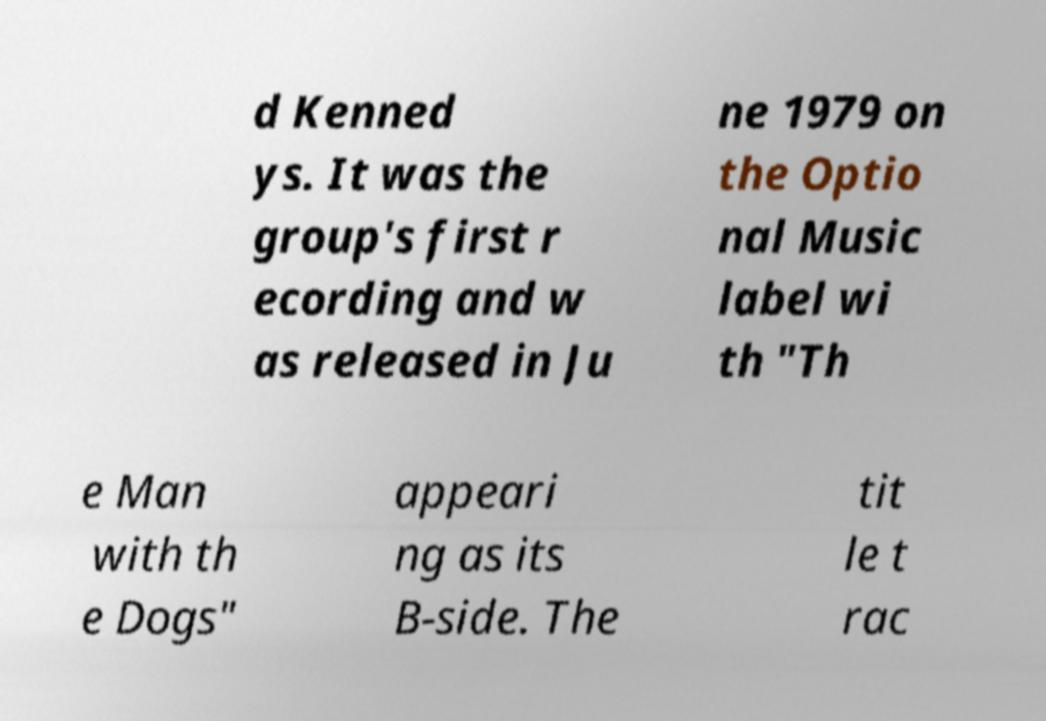Please identify and transcribe the text found in this image. d Kenned ys. It was the group's first r ecording and w as released in Ju ne 1979 on the Optio nal Music label wi th "Th e Man with th e Dogs" appeari ng as its B-side. The tit le t rac 